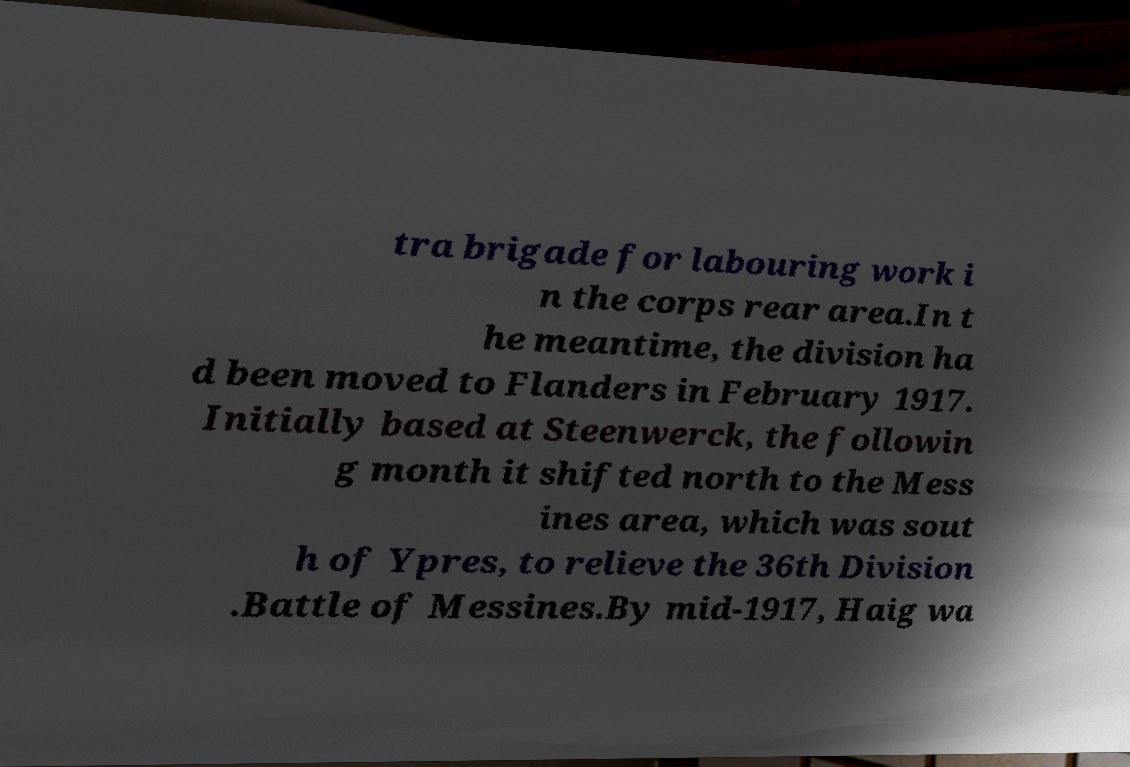Can you read and provide the text displayed in the image?This photo seems to have some interesting text. Can you extract and type it out for me? tra brigade for labouring work i n the corps rear area.In t he meantime, the division ha d been moved to Flanders in February 1917. Initially based at Steenwerck, the followin g month it shifted north to the Mess ines area, which was sout h of Ypres, to relieve the 36th Division .Battle of Messines.By mid-1917, Haig wa 